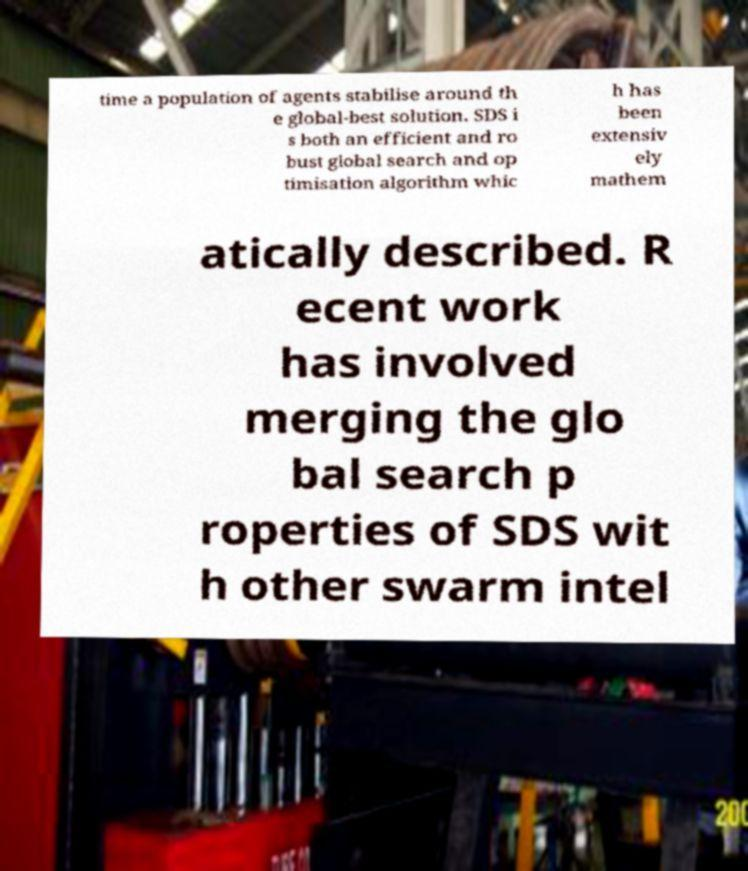Can you accurately transcribe the text from the provided image for me? time a population of agents stabilise around th e global-best solution. SDS i s both an efficient and ro bust global search and op timisation algorithm whic h has been extensiv ely mathem atically described. R ecent work has involved merging the glo bal search p roperties of SDS wit h other swarm intel 